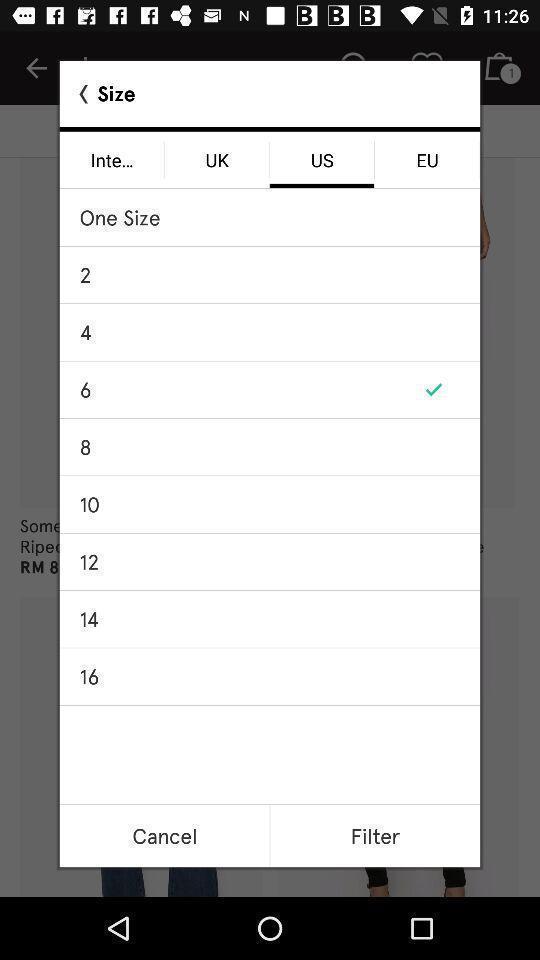Summarize the main components in this picture. Popup page for choosing size for footwear of shopping app. 